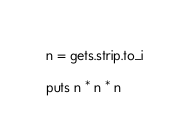Convert code to text. <code><loc_0><loc_0><loc_500><loc_500><_Ruby_>n = gets.strip.to_i

puts n * n * n</code> 